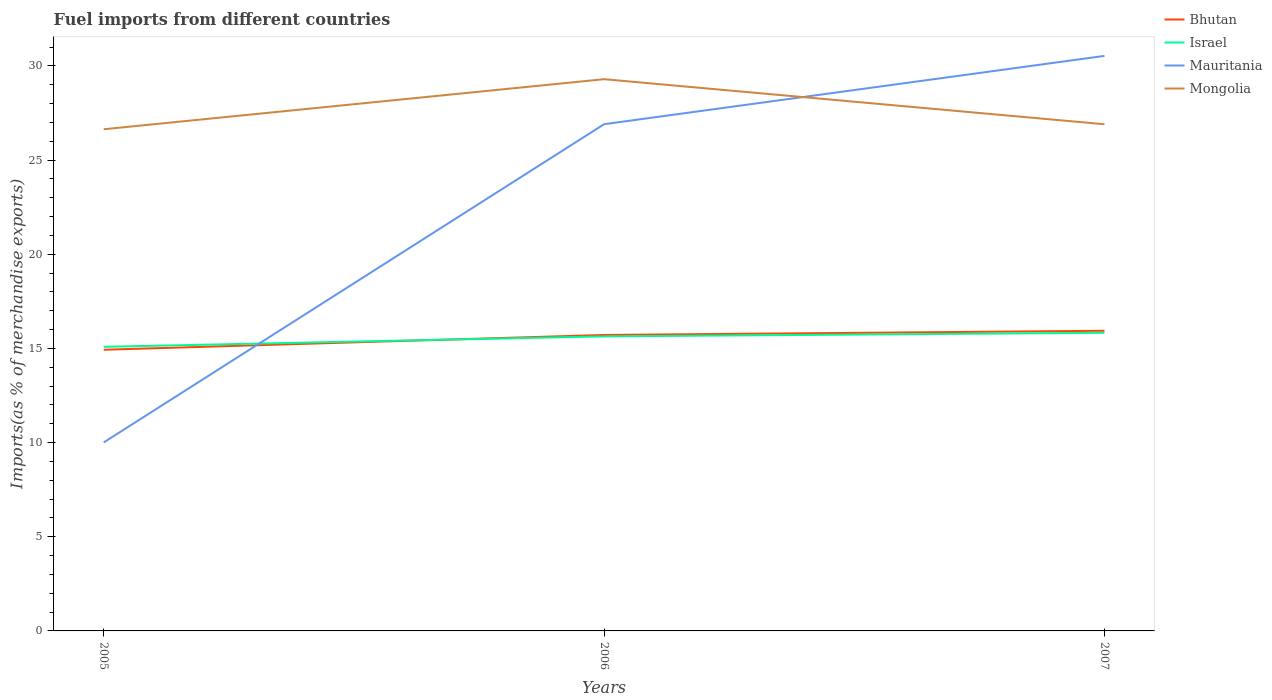How many different coloured lines are there?
Provide a succinct answer. 4. Is the number of lines equal to the number of legend labels?
Your answer should be compact. Yes. Across all years, what is the maximum percentage of imports to different countries in Israel?
Offer a terse response. 15.09. What is the total percentage of imports to different countries in Israel in the graph?
Give a very brief answer. -0.19. What is the difference between the highest and the second highest percentage of imports to different countries in Mauritania?
Keep it short and to the point. 20.52. What is the difference between the highest and the lowest percentage of imports to different countries in Israel?
Keep it short and to the point. 2. Is the percentage of imports to different countries in Israel strictly greater than the percentage of imports to different countries in Bhutan over the years?
Provide a short and direct response. No. How many lines are there?
Keep it short and to the point. 4. How many years are there in the graph?
Ensure brevity in your answer.  3. Does the graph contain grids?
Your response must be concise. No. How are the legend labels stacked?
Offer a terse response. Vertical. What is the title of the graph?
Offer a terse response. Fuel imports from different countries. What is the label or title of the Y-axis?
Provide a succinct answer. Imports(as % of merchandise exports). What is the Imports(as % of merchandise exports) in Bhutan in 2005?
Give a very brief answer. 14.93. What is the Imports(as % of merchandise exports) in Israel in 2005?
Give a very brief answer. 15.09. What is the Imports(as % of merchandise exports) in Mauritania in 2005?
Give a very brief answer. 10.01. What is the Imports(as % of merchandise exports) of Mongolia in 2005?
Offer a terse response. 26.64. What is the Imports(as % of merchandise exports) of Bhutan in 2006?
Keep it short and to the point. 15.71. What is the Imports(as % of merchandise exports) in Israel in 2006?
Give a very brief answer. 15.64. What is the Imports(as % of merchandise exports) of Mauritania in 2006?
Provide a succinct answer. 26.91. What is the Imports(as % of merchandise exports) in Mongolia in 2006?
Make the answer very short. 29.3. What is the Imports(as % of merchandise exports) of Bhutan in 2007?
Give a very brief answer. 15.94. What is the Imports(as % of merchandise exports) in Israel in 2007?
Make the answer very short. 15.83. What is the Imports(as % of merchandise exports) in Mauritania in 2007?
Keep it short and to the point. 30.53. What is the Imports(as % of merchandise exports) of Mongolia in 2007?
Offer a very short reply. 26.9. Across all years, what is the maximum Imports(as % of merchandise exports) of Bhutan?
Ensure brevity in your answer.  15.94. Across all years, what is the maximum Imports(as % of merchandise exports) in Israel?
Provide a succinct answer. 15.83. Across all years, what is the maximum Imports(as % of merchandise exports) of Mauritania?
Your answer should be very brief. 30.53. Across all years, what is the maximum Imports(as % of merchandise exports) in Mongolia?
Your answer should be very brief. 29.3. Across all years, what is the minimum Imports(as % of merchandise exports) in Bhutan?
Give a very brief answer. 14.93. Across all years, what is the minimum Imports(as % of merchandise exports) in Israel?
Your answer should be compact. 15.09. Across all years, what is the minimum Imports(as % of merchandise exports) in Mauritania?
Provide a short and direct response. 10.01. Across all years, what is the minimum Imports(as % of merchandise exports) of Mongolia?
Give a very brief answer. 26.64. What is the total Imports(as % of merchandise exports) of Bhutan in the graph?
Your answer should be compact. 46.58. What is the total Imports(as % of merchandise exports) in Israel in the graph?
Give a very brief answer. 46.56. What is the total Imports(as % of merchandise exports) of Mauritania in the graph?
Your answer should be compact. 67.45. What is the total Imports(as % of merchandise exports) of Mongolia in the graph?
Your response must be concise. 82.84. What is the difference between the Imports(as % of merchandise exports) in Bhutan in 2005 and that in 2006?
Your answer should be very brief. -0.79. What is the difference between the Imports(as % of merchandise exports) in Israel in 2005 and that in 2006?
Ensure brevity in your answer.  -0.55. What is the difference between the Imports(as % of merchandise exports) in Mauritania in 2005 and that in 2006?
Keep it short and to the point. -16.9. What is the difference between the Imports(as % of merchandise exports) in Mongolia in 2005 and that in 2006?
Offer a very short reply. -2.66. What is the difference between the Imports(as % of merchandise exports) in Bhutan in 2005 and that in 2007?
Give a very brief answer. -1.01. What is the difference between the Imports(as % of merchandise exports) in Israel in 2005 and that in 2007?
Provide a succinct answer. -0.74. What is the difference between the Imports(as % of merchandise exports) in Mauritania in 2005 and that in 2007?
Make the answer very short. -20.52. What is the difference between the Imports(as % of merchandise exports) of Mongolia in 2005 and that in 2007?
Your answer should be compact. -0.27. What is the difference between the Imports(as % of merchandise exports) in Bhutan in 2006 and that in 2007?
Give a very brief answer. -0.22. What is the difference between the Imports(as % of merchandise exports) in Israel in 2006 and that in 2007?
Give a very brief answer. -0.19. What is the difference between the Imports(as % of merchandise exports) in Mauritania in 2006 and that in 2007?
Your answer should be compact. -3.63. What is the difference between the Imports(as % of merchandise exports) of Mongolia in 2006 and that in 2007?
Offer a terse response. 2.39. What is the difference between the Imports(as % of merchandise exports) of Bhutan in 2005 and the Imports(as % of merchandise exports) of Israel in 2006?
Provide a succinct answer. -0.71. What is the difference between the Imports(as % of merchandise exports) in Bhutan in 2005 and the Imports(as % of merchandise exports) in Mauritania in 2006?
Your answer should be compact. -11.98. What is the difference between the Imports(as % of merchandise exports) in Bhutan in 2005 and the Imports(as % of merchandise exports) in Mongolia in 2006?
Keep it short and to the point. -14.37. What is the difference between the Imports(as % of merchandise exports) of Israel in 2005 and the Imports(as % of merchandise exports) of Mauritania in 2006?
Offer a very short reply. -11.82. What is the difference between the Imports(as % of merchandise exports) of Israel in 2005 and the Imports(as % of merchandise exports) of Mongolia in 2006?
Provide a succinct answer. -14.21. What is the difference between the Imports(as % of merchandise exports) in Mauritania in 2005 and the Imports(as % of merchandise exports) in Mongolia in 2006?
Offer a very short reply. -19.29. What is the difference between the Imports(as % of merchandise exports) in Bhutan in 2005 and the Imports(as % of merchandise exports) in Israel in 2007?
Offer a very short reply. -0.9. What is the difference between the Imports(as % of merchandise exports) in Bhutan in 2005 and the Imports(as % of merchandise exports) in Mauritania in 2007?
Provide a short and direct response. -15.6. What is the difference between the Imports(as % of merchandise exports) in Bhutan in 2005 and the Imports(as % of merchandise exports) in Mongolia in 2007?
Your answer should be very brief. -11.97. What is the difference between the Imports(as % of merchandise exports) in Israel in 2005 and the Imports(as % of merchandise exports) in Mauritania in 2007?
Offer a very short reply. -15.45. What is the difference between the Imports(as % of merchandise exports) in Israel in 2005 and the Imports(as % of merchandise exports) in Mongolia in 2007?
Ensure brevity in your answer.  -11.82. What is the difference between the Imports(as % of merchandise exports) in Mauritania in 2005 and the Imports(as % of merchandise exports) in Mongolia in 2007?
Offer a terse response. -16.89. What is the difference between the Imports(as % of merchandise exports) in Bhutan in 2006 and the Imports(as % of merchandise exports) in Israel in 2007?
Your answer should be compact. -0.12. What is the difference between the Imports(as % of merchandise exports) of Bhutan in 2006 and the Imports(as % of merchandise exports) of Mauritania in 2007?
Your response must be concise. -14.82. What is the difference between the Imports(as % of merchandise exports) of Bhutan in 2006 and the Imports(as % of merchandise exports) of Mongolia in 2007?
Offer a terse response. -11.19. What is the difference between the Imports(as % of merchandise exports) in Israel in 2006 and the Imports(as % of merchandise exports) in Mauritania in 2007?
Offer a terse response. -14.89. What is the difference between the Imports(as % of merchandise exports) of Israel in 2006 and the Imports(as % of merchandise exports) of Mongolia in 2007?
Keep it short and to the point. -11.26. What is the difference between the Imports(as % of merchandise exports) in Mauritania in 2006 and the Imports(as % of merchandise exports) in Mongolia in 2007?
Offer a very short reply. 0. What is the average Imports(as % of merchandise exports) in Bhutan per year?
Your answer should be very brief. 15.53. What is the average Imports(as % of merchandise exports) of Israel per year?
Your answer should be very brief. 15.52. What is the average Imports(as % of merchandise exports) in Mauritania per year?
Provide a succinct answer. 22.48. What is the average Imports(as % of merchandise exports) of Mongolia per year?
Offer a terse response. 27.61. In the year 2005, what is the difference between the Imports(as % of merchandise exports) in Bhutan and Imports(as % of merchandise exports) in Israel?
Ensure brevity in your answer.  -0.16. In the year 2005, what is the difference between the Imports(as % of merchandise exports) of Bhutan and Imports(as % of merchandise exports) of Mauritania?
Offer a terse response. 4.92. In the year 2005, what is the difference between the Imports(as % of merchandise exports) of Bhutan and Imports(as % of merchandise exports) of Mongolia?
Your response must be concise. -11.71. In the year 2005, what is the difference between the Imports(as % of merchandise exports) in Israel and Imports(as % of merchandise exports) in Mauritania?
Ensure brevity in your answer.  5.08. In the year 2005, what is the difference between the Imports(as % of merchandise exports) of Israel and Imports(as % of merchandise exports) of Mongolia?
Your answer should be compact. -11.55. In the year 2005, what is the difference between the Imports(as % of merchandise exports) in Mauritania and Imports(as % of merchandise exports) in Mongolia?
Your answer should be very brief. -16.63. In the year 2006, what is the difference between the Imports(as % of merchandise exports) in Bhutan and Imports(as % of merchandise exports) in Israel?
Keep it short and to the point. 0.07. In the year 2006, what is the difference between the Imports(as % of merchandise exports) of Bhutan and Imports(as % of merchandise exports) of Mauritania?
Provide a short and direct response. -11.19. In the year 2006, what is the difference between the Imports(as % of merchandise exports) of Bhutan and Imports(as % of merchandise exports) of Mongolia?
Make the answer very short. -13.58. In the year 2006, what is the difference between the Imports(as % of merchandise exports) in Israel and Imports(as % of merchandise exports) in Mauritania?
Your answer should be compact. -11.27. In the year 2006, what is the difference between the Imports(as % of merchandise exports) in Israel and Imports(as % of merchandise exports) in Mongolia?
Your answer should be very brief. -13.66. In the year 2006, what is the difference between the Imports(as % of merchandise exports) in Mauritania and Imports(as % of merchandise exports) in Mongolia?
Your response must be concise. -2.39. In the year 2007, what is the difference between the Imports(as % of merchandise exports) in Bhutan and Imports(as % of merchandise exports) in Israel?
Keep it short and to the point. 0.11. In the year 2007, what is the difference between the Imports(as % of merchandise exports) of Bhutan and Imports(as % of merchandise exports) of Mauritania?
Your response must be concise. -14.6. In the year 2007, what is the difference between the Imports(as % of merchandise exports) of Bhutan and Imports(as % of merchandise exports) of Mongolia?
Keep it short and to the point. -10.97. In the year 2007, what is the difference between the Imports(as % of merchandise exports) of Israel and Imports(as % of merchandise exports) of Mauritania?
Provide a succinct answer. -14.7. In the year 2007, what is the difference between the Imports(as % of merchandise exports) in Israel and Imports(as % of merchandise exports) in Mongolia?
Offer a very short reply. -11.07. In the year 2007, what is the difference between the Imports(as % of merchandise exports) in Mauritania and Imports(as % of merchandise exports) in Mongolia?
Your response must be concise. 3.63. What is the ratio of the Imports(as % of merchandise exports) of Bhutan in 2005 to that in 2006?
Ensure brevity in your answer.  0.95. What is the ratio of the Imports(as % of merchandise exports) in Israel in 2005 to that in 2006?
Give a very brief answer. 0.96. What is the ratio of the Imports(as % of merchandise exports) in Mauritania in 2005 to that in 2006?
Offer a terse response. 0.37. What is the ratio of the Imports(as % of merchandise exports) of Mongolia in 2005 to that in 2006?
Your response must be concise. 0.91. What is the ratio of the Imports(as % of merchandise exports) of Bhutan in 2005 to that in 2007?
Make the answer very short. 0.94. What is the ratio of the Imports(as % of merchandise exports) of Israel in 2005 to that in 2007?
Offer a very short reply. 0.95. What is the ratio of the Imports(as % of merchandise exports) of Mauritania in 2005 to that in 2007?
Make the answer very short. 0.33. What is the ratio of the Imports(as % of merchandise exports) of Israel in 2006 to that in 2007?
Your answer should be compact. 0.99. What is the ratio of the Imports(as % of merchandise exports) in Mauritania in 2006 to that in 2007?
Offer a terse response. 0.88. What is the ratio of the Imports(as % of merchandise exports) of Mongolia in 2006 to that in 2007?
Your response must be concise. 1.09. What is the difference between the highest and the second highest Imports(as % of merchandise exports) in Bhutan?
Your answer should be very brief. 0.22. What is the difference between the highest and the second highest Imports(as % of merchandise exports) in Israel?
Offer a very short reply. 0.19. What is the difference between the highest and the second highest Imports(as % of merchandise exports) in Mauritania?
Offer a terse response. 3.63. What is the difference between the highest and the second highest Imports(as % of merchandise exports) of Mongolia?
Make the answer very short. 2.39. What is the difference between the highest and the lowest Imports(as % of merchandise exports) in Bhutan?
Ensure brevity in your answer.  1.01. What is the difference between the highest and the lowest Imports(as % of merchandise exports) of Israel?
Offer a very short reply. 0.74. What is the difference between the highest and the lowest Imports(as % of merchandise exports) in Mauritania?
Give a very brief answer. 20.52. What is the difference between the highest and the lowest Imports(as % of merchandise exports) in Mongolia?
Your response must be concise. 2.66. 